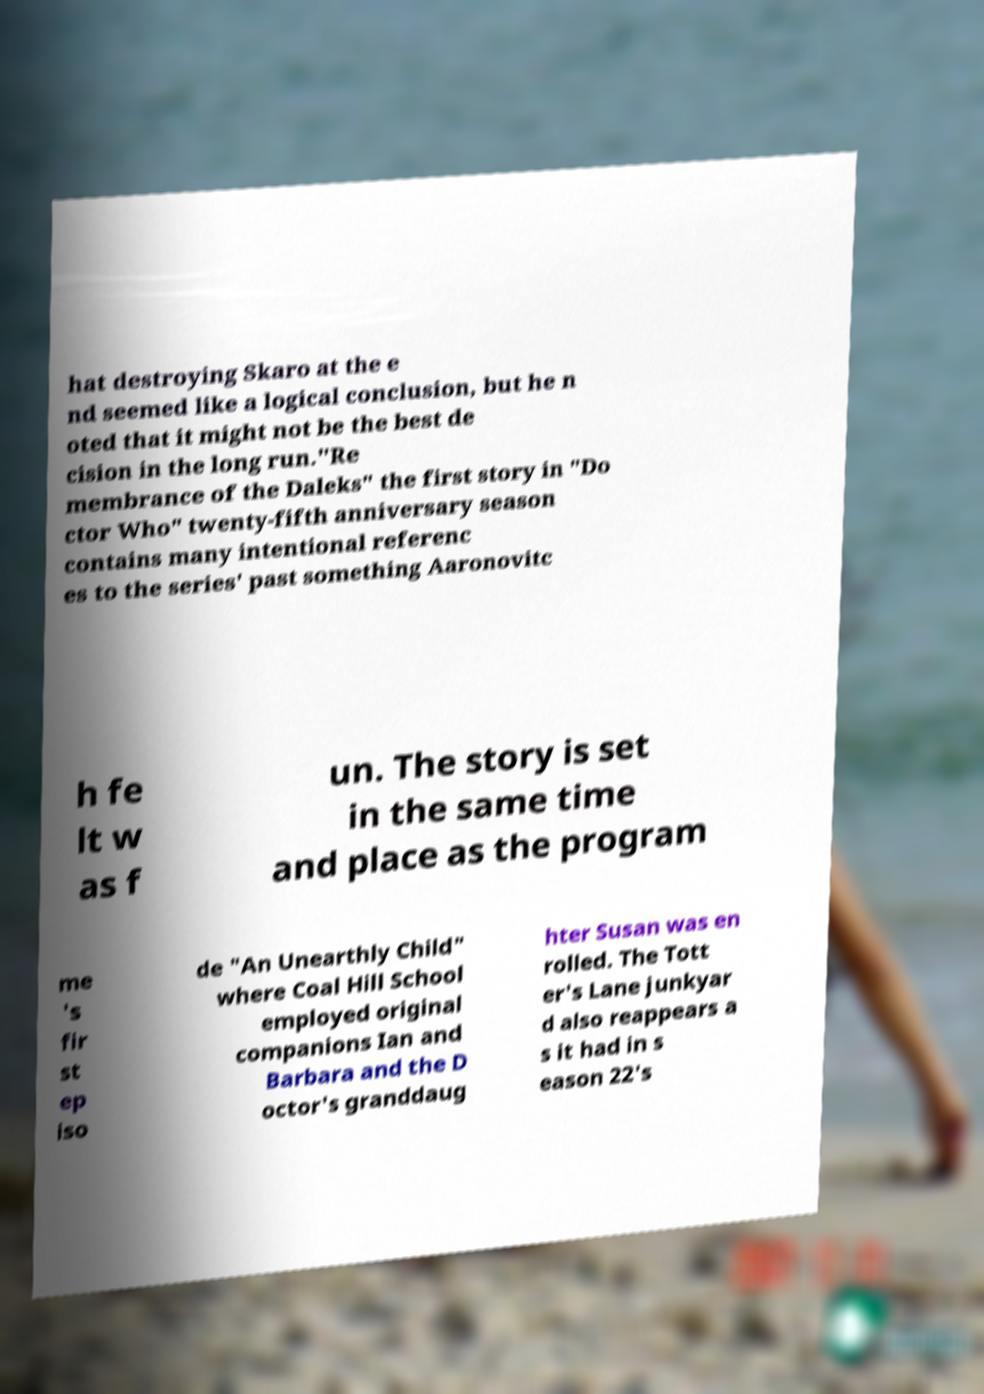There's text embedded in this image that I need extracted. Can you transcribe it verbatim? hat destroying Skaro at the e nd seemed like a logical conclusion, but he n oted that it might not be the best de cision in the long run."Re membrance of the Daleks" the first story in "Do ctor Who" twenty-fifth anniversary season contains many intentional referenc es to the series' past something Aaronovitc h fe lt w as f un. The story is set in the same time and place as the program me 's fir st ep iso de "An Unearthly Child" where Coal Hill School employed original companions Ian and Barbara and the D octor's granddaug hter Susan was en rolled. The Tott er's Lane junkyar d also reappears a s it had in s eason 22's 